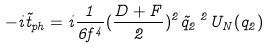Convert formula to latex. <formula><loc_0><loc_0><loc_500><loc_500>- i \tilde { t } _ { p h } = i \frac { 1 } { 6 f ^ { 4 } } ( \frac { D + F } { 2 } ) ^ { 2 } \vec { q } _ { 2 } \, ^ { 2 } U _ { N } ( q _ { 2 } )</formula> 